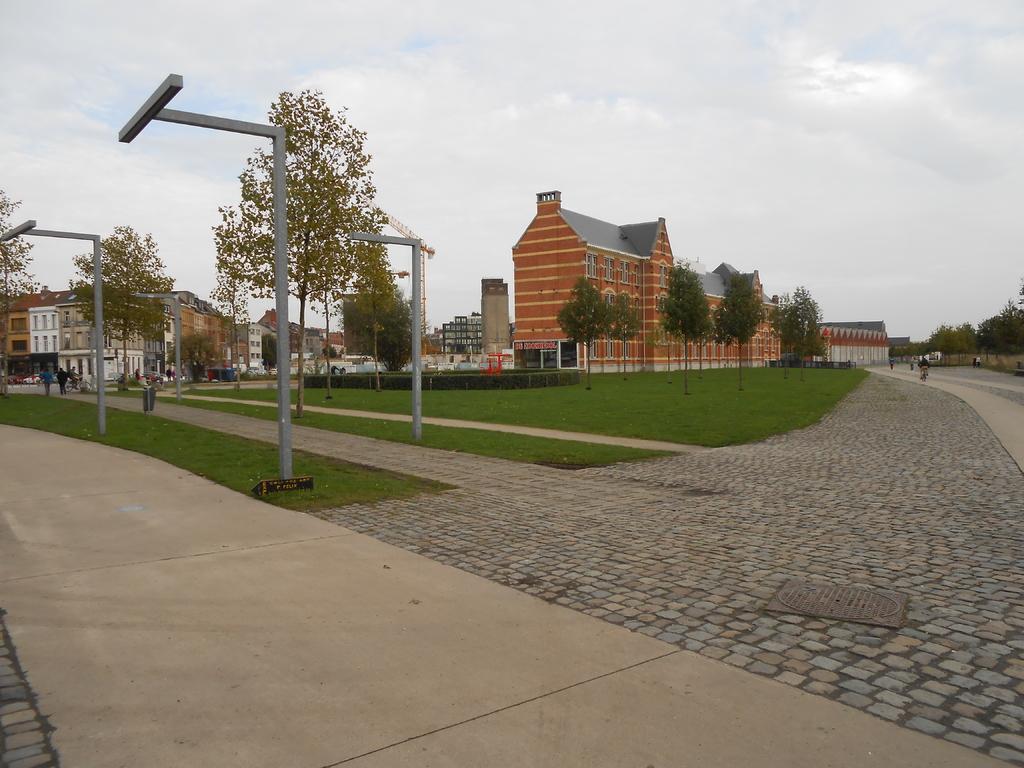Please provide a concise description of this image. At the center of the image there are buildings, in front of the buildings there are trees and few are walking on the path, there are few poles. In the background there is a sky. 